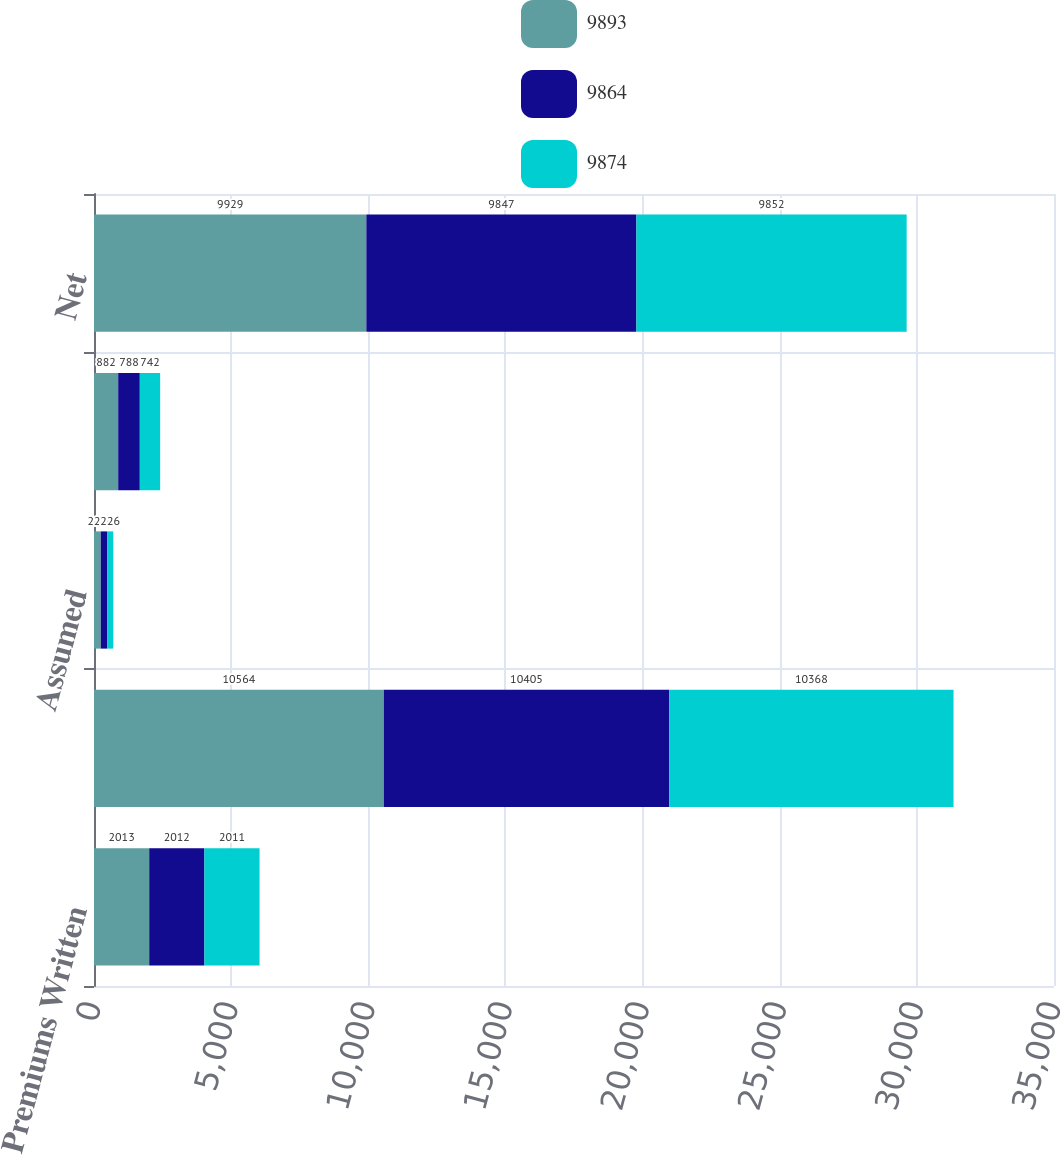Convert chart. <chart><loc_0><loc_0><loc_500><loc_500><stacked_bar_chart><ecel><fcel>Premiums Written<fcel>Direct<fcel>Assumed<fcel>Ceded<fcel>Net<nl><fcel>9893<fcel>2013<fcel>10564<fcel>247<fcel>882<fcel>9929<nl><fcel>9864<fcel>2012<fcel>10405<fcel>230<fcel>788<fcel>9847<nl><fcel>9874<fcel>2011<fcel>10368<fcel>226<fcel>742<fcel>9852<nl></chart> 